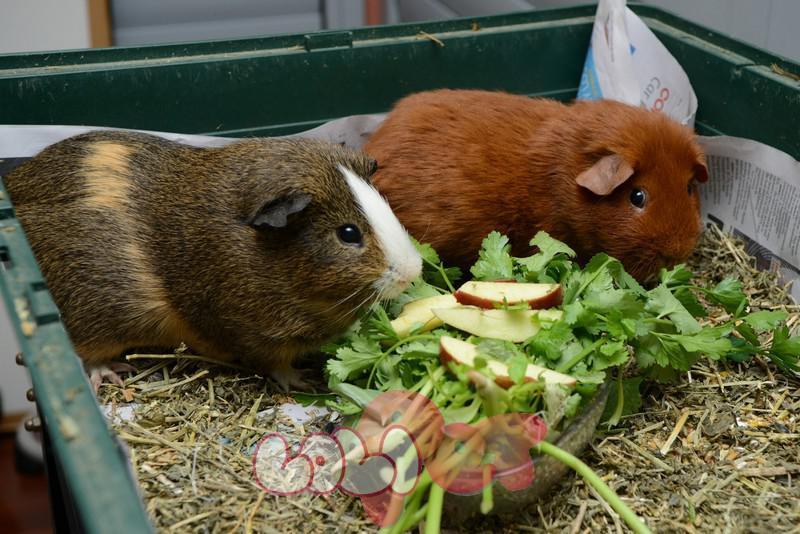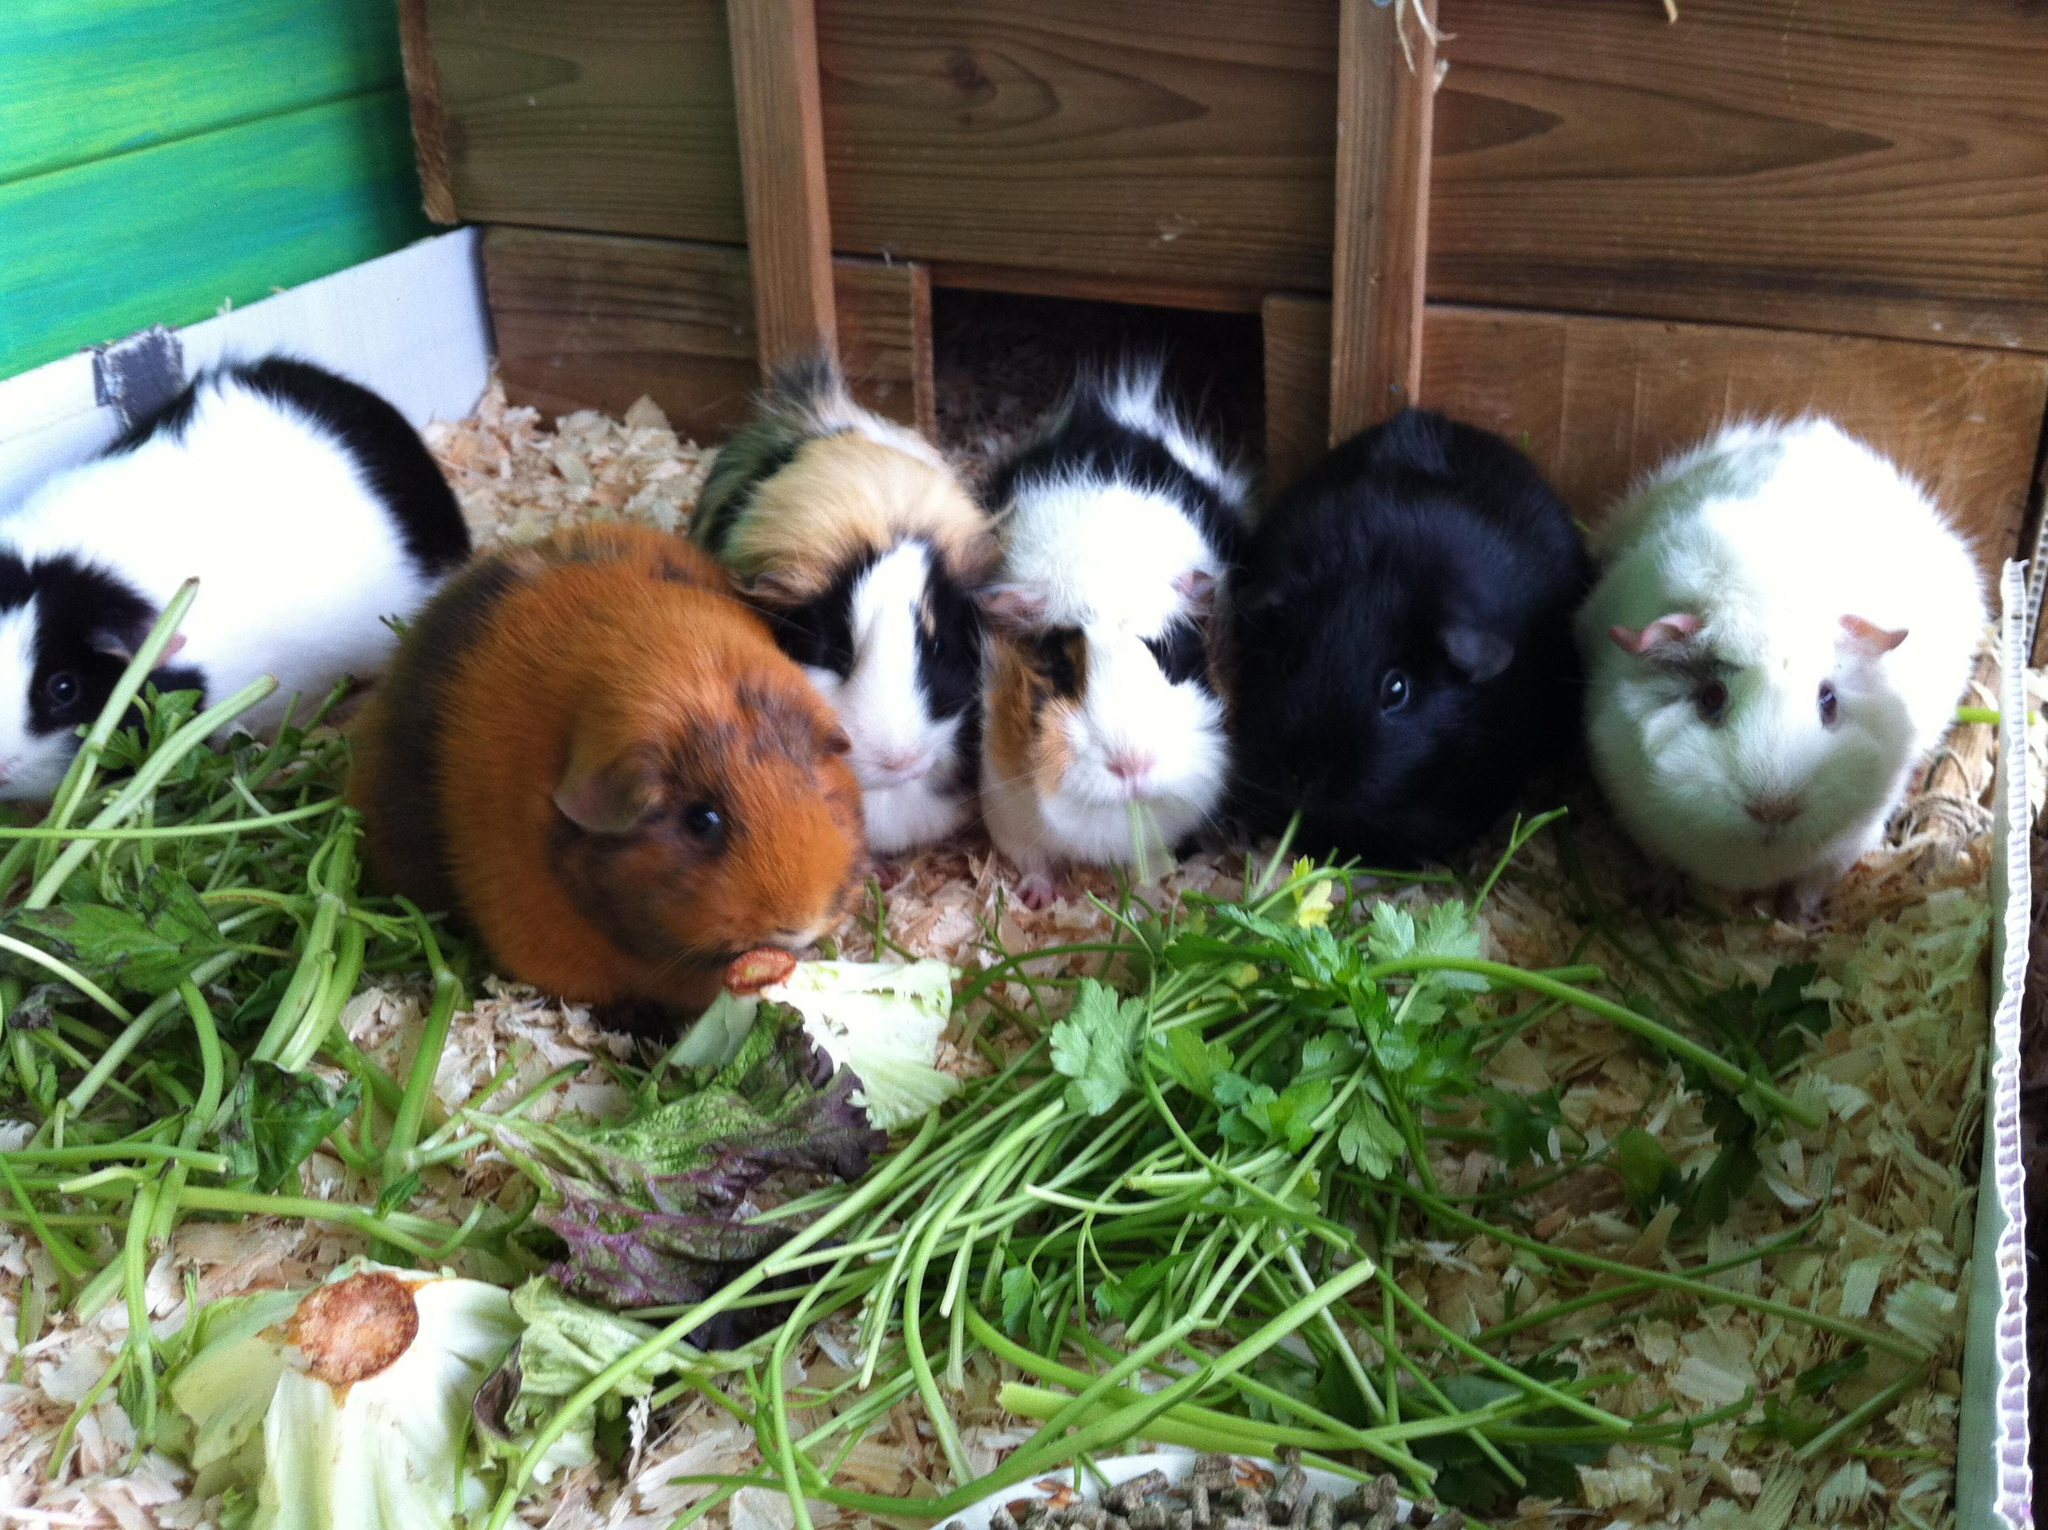The first image is the image on the left, the second image is the image on the right. For the images displayed, is the sentence "Multiple hamsters surround a pile of leafy greens in at least one image." factually correct? Answer yes or no. Yes. The first image is the image on the left, the second image is the image on the right. Examine the images to the left and right. Is the description "One image shows exactly one guinea pig surrounded by butterflies while the other image shows several guinea pigs." accurate? Answer yes or no. No. 